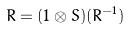<formula> <loc_0><loc_0><loc_500><loc_500>R = ( 1 \otimes S ) ( R ^ { - 1 } )</formula> 